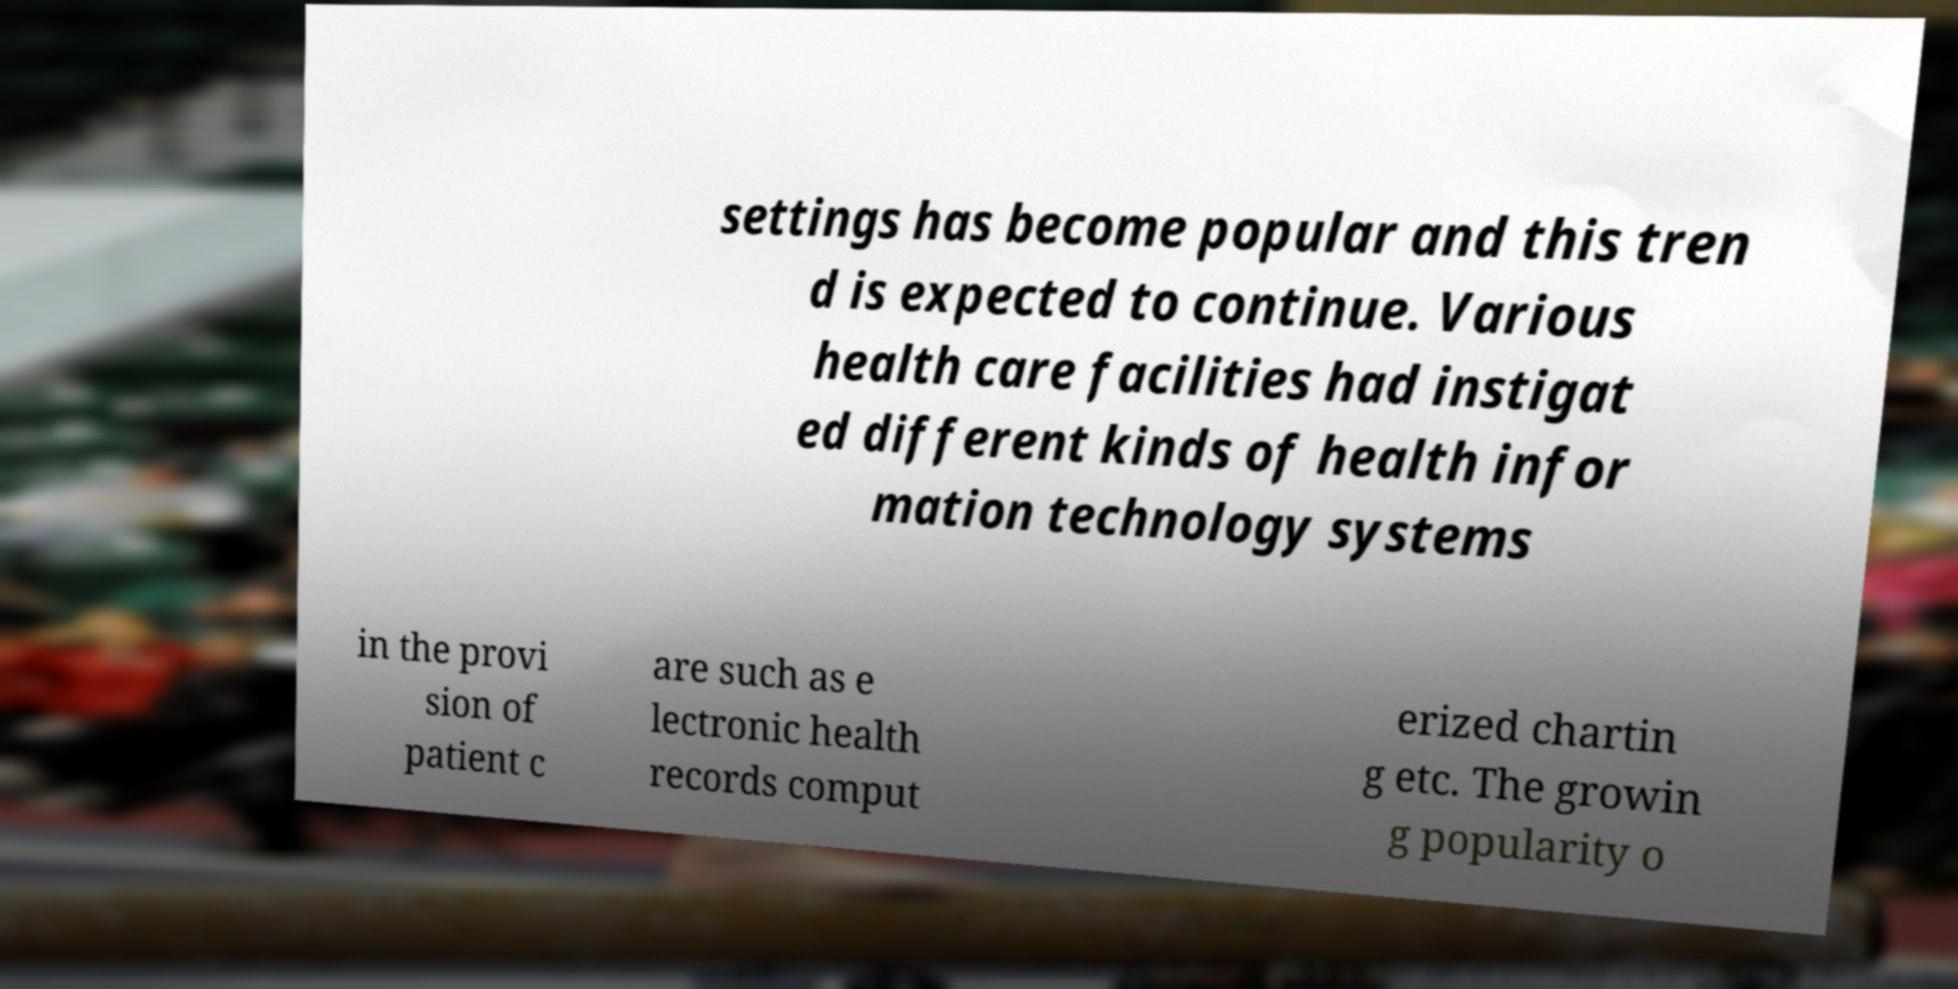Can you accurately transcribe the text from the provided image for me? settings has become popular and this tren d is expected to continue. Various health care facilities had instigat ed different kinds of health infor mation technology systems in the provi sion of patient c are such as e lectronic health records comput erized chartin g etc. The growin g popularity o 